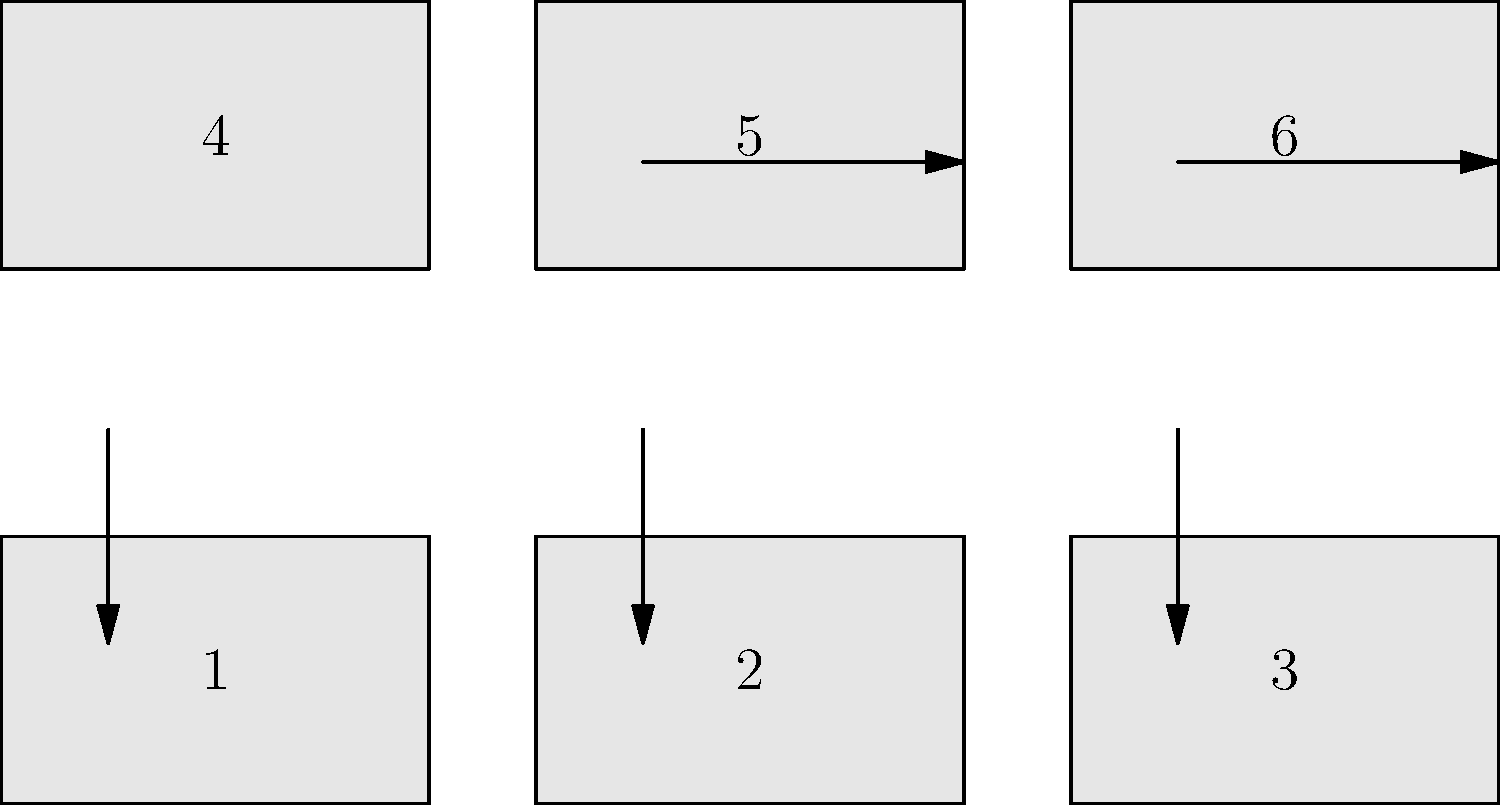In a United Nations assembly, flags are arranged in a 2x3 grid. The rules for arrangement are:
1. Indonesia's flag must be in the top row.
2. The USA flag must be directly below Indonesia's flag.
3. Japan's flag must be to the right of Indonesia's flag.
4. South Korea's flag must be in the bottom-right corner.
5. France's flag must be to the left of South Korea's flag.
6. The remaining position is for Germany's flag.

Based on these rules and the numbered positions in the diagram, what is the correct arrangement of flags? List the countries in order from position 1 to 6. Let's approach this step-by-step:

1. Indonesia's flag must be in the top row, which means it can be in position 1, 2, or 3.

2. The USA flag must be directly below Indonesia's flag. This narrows down Indonesia's position to 1 or 2, as position 3 doesn't have a space below it.

3. Japan's flag must be to the right of Indonesia's flag. This confirms that Indonesia's flag must be in position 1, with Japan in position 2, and the USA in position 4.

4. South Korea's flag must be in the bottom-right corner, which is position 6.

5. France's flag must be to the left of South Korea's flag, placing it in position 5.

6. The remaining position, 3, is for Germany's flag.

Therefore, the arrangement from position 1 to 6 is:
1. Indonesia
2. Japan
3. Germany
4. USA
5. France
6. South Korea
Answer: Indonesia, Japan, Germany, USA, France, South Korea 